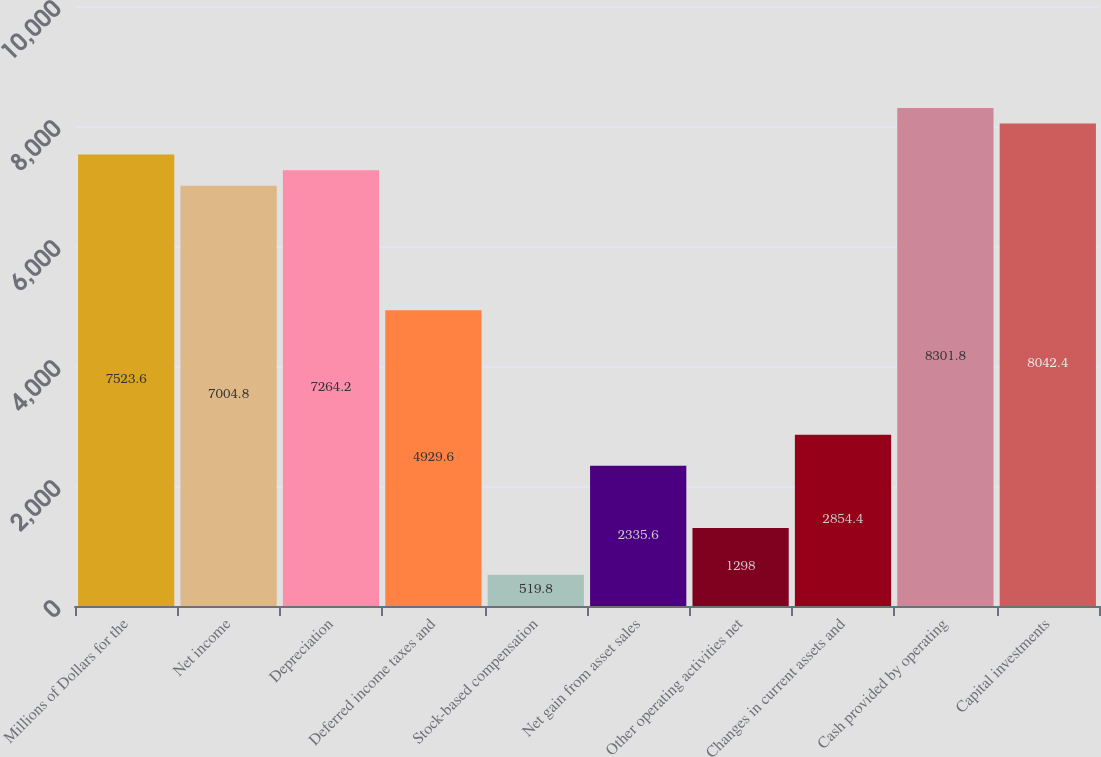<chart> <loc_0><loc_0><loc_500><loc_500><bar_chart><fcel>Millions of Dollars for the<fcel>Net income<fcel>Depreciation<fcel>Deferred income taxes and<fcel>Stock-based compensation<fcel>Net gain from asset sales<fcel>Other operating activities net<fcel>Changes in current assets and<fcel>Cash provided by operating<fcel>Capital investments<nl><fcel>7523.6<fcel>7004.8<fcel>7264.2<fcel>4929.6<fcel>519.8<fcel>2335.6<fcel>1298<fcel>2854.4<fcel>8301.8<fcel>8042.4<nl></chart> 